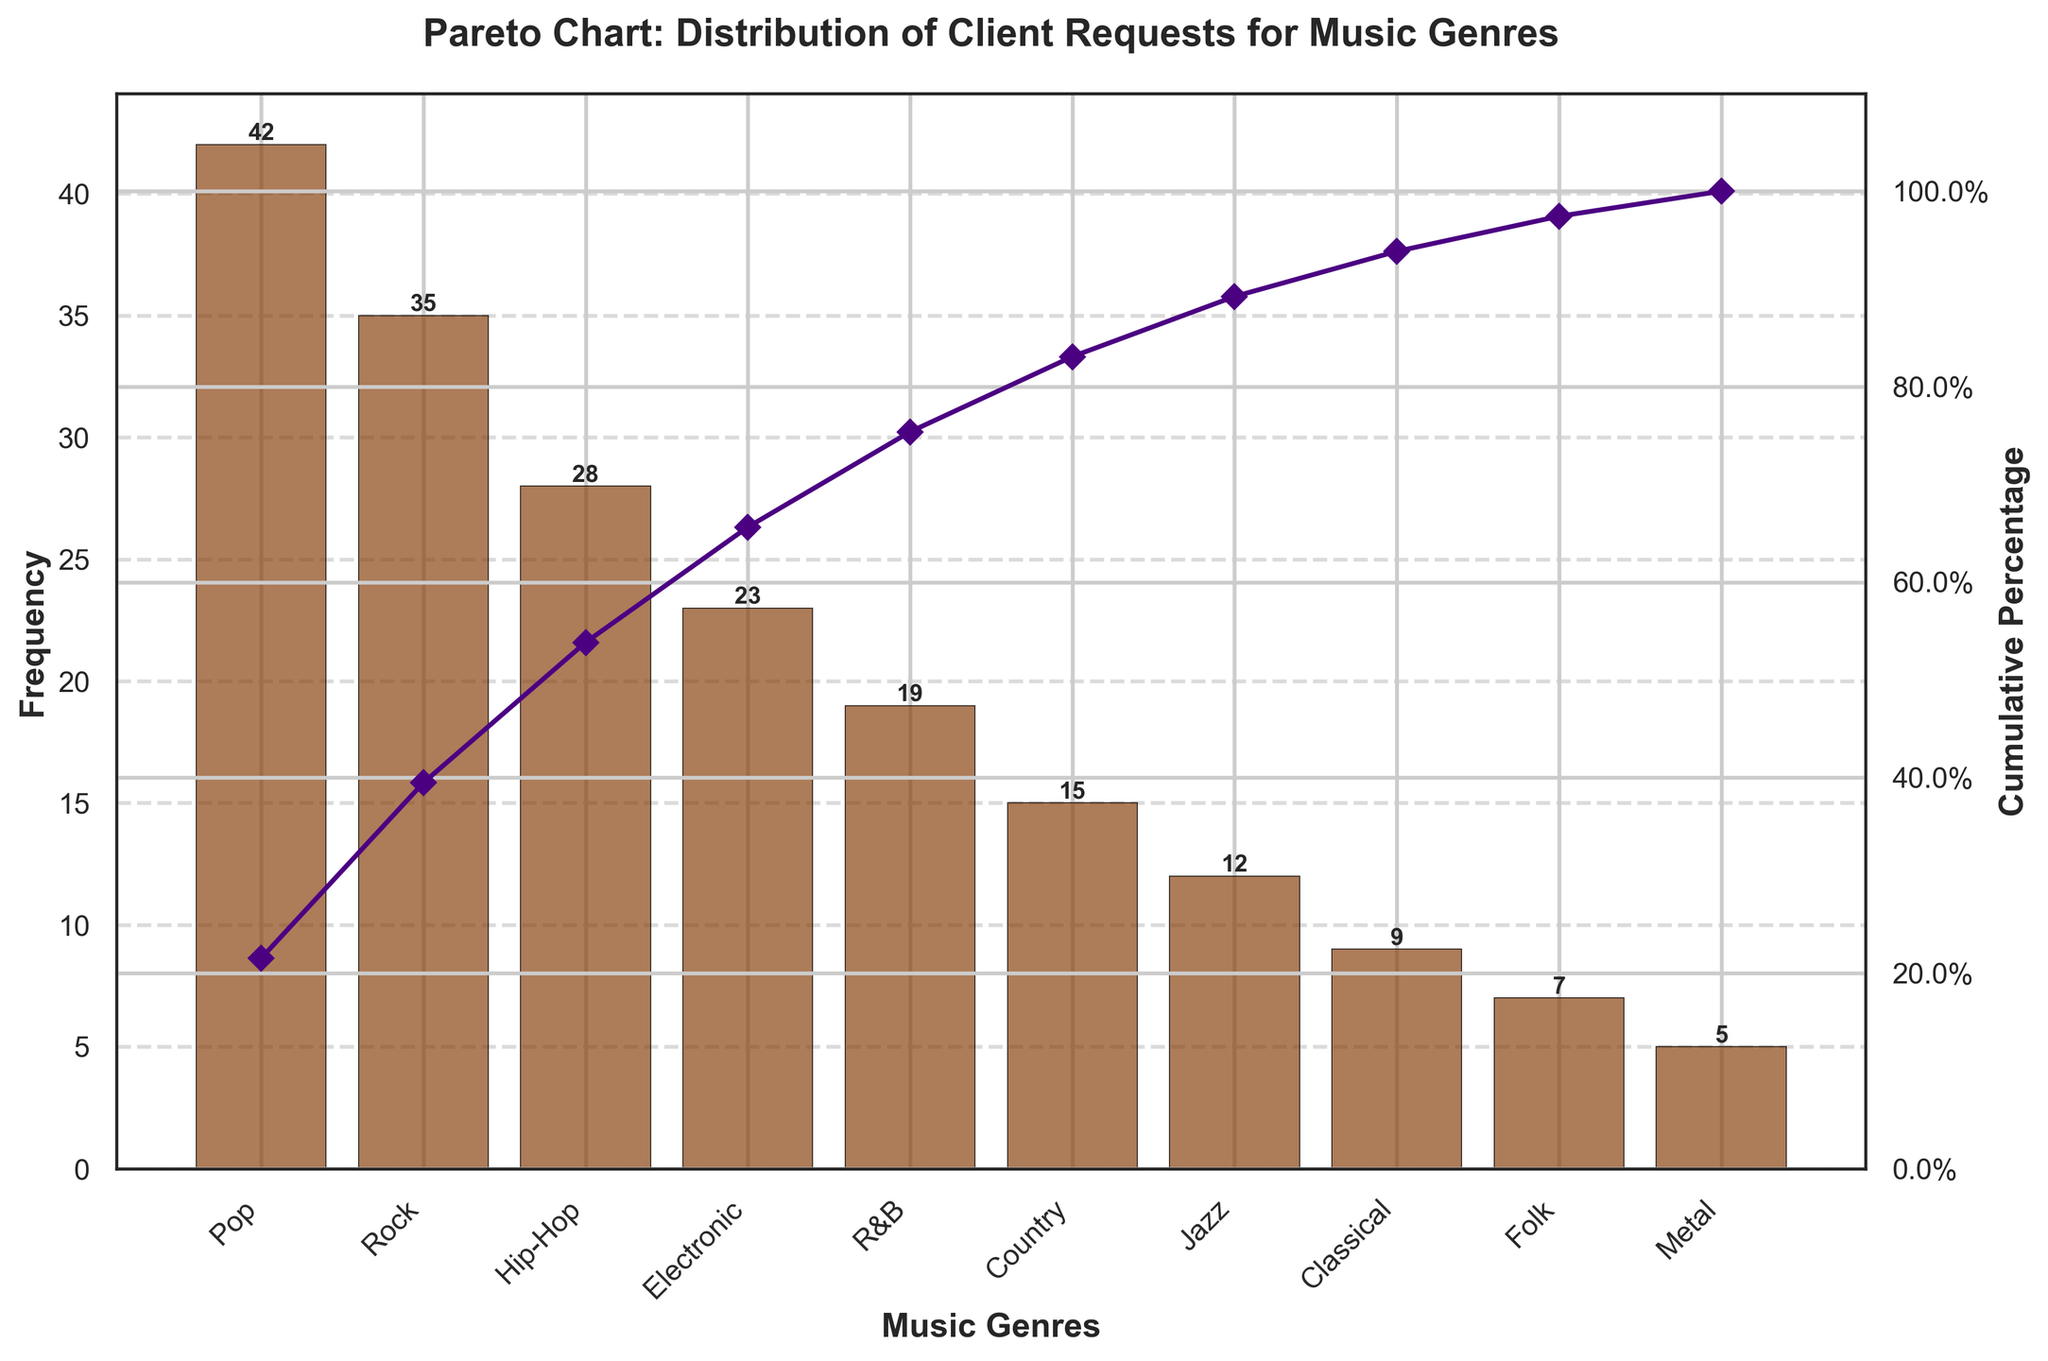What's the title of the chart? The title of the chart is above the main part of the figure in large, bold text.
Answer: Pareto Chart: Distribution of Client Requests for Music Genres What's the most requested music genre by clients? By examining the height of the bars, the highest bar represents the most requested genre.
Answer: Pop What's the cumulative percentage for the top 3 music genres? From the cumulative percentage line, add the values for the first three genres (Pop, Rock, Hip-Hop).
Answer: 52.7% Which genre has the lowest frequency of requests? The smallest bar in the chart indicates the genre with the lowest frequency.
Answer: Metal What's the cumulative percentage immediately after Jazz? Identify Jazz on the x-axis, then read the cumulative percentage right above it.
Answer: 88.6% How many more requests does Pop have compared to Hip-Hop? Subtract the frequency of Hip-Hop from the frequency of Pop.
Answer: 14 What cumulative percentage does the line cross before reaching 100%? Look at the highest point the cumulative percentage line reaches on the y2 axis before it touches 100%.
Answer: 96.9% What’s the total number of client requests for all genres combined? Sum all the frequencies of the genres given in the data.
Answer: 195 Which genres contribute to 80% of the cumulative requests? From the cumulative line, identify the genres up to where the line crosses the 80% mark.
Answer: Pop, Rock, Hip-Hop, Electronic, R&B How does the frequency of Country compare to Jazz? Compare the heights of the bars for Country and Jazz.
Answer: Country is 3 more than Jazz 